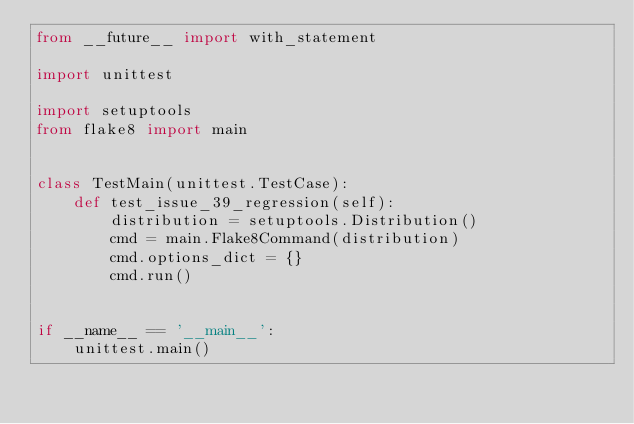Convert code to text. <code><loc_0><loc_0><loc_500><loc_500><_Python_>from __future__ import with_statementimport unittestimport setuptoolsfrom flake8 import mainclass TestMain(unittest.TestCase):    def test_issue_39_regression(self):        distribution = setuptools.Distribution()        cmd = main.Flake8Command(distribution)        cmd.options_dict = {}        cmd.run()if __name__ == '__main__':    unittest.main()</code> 